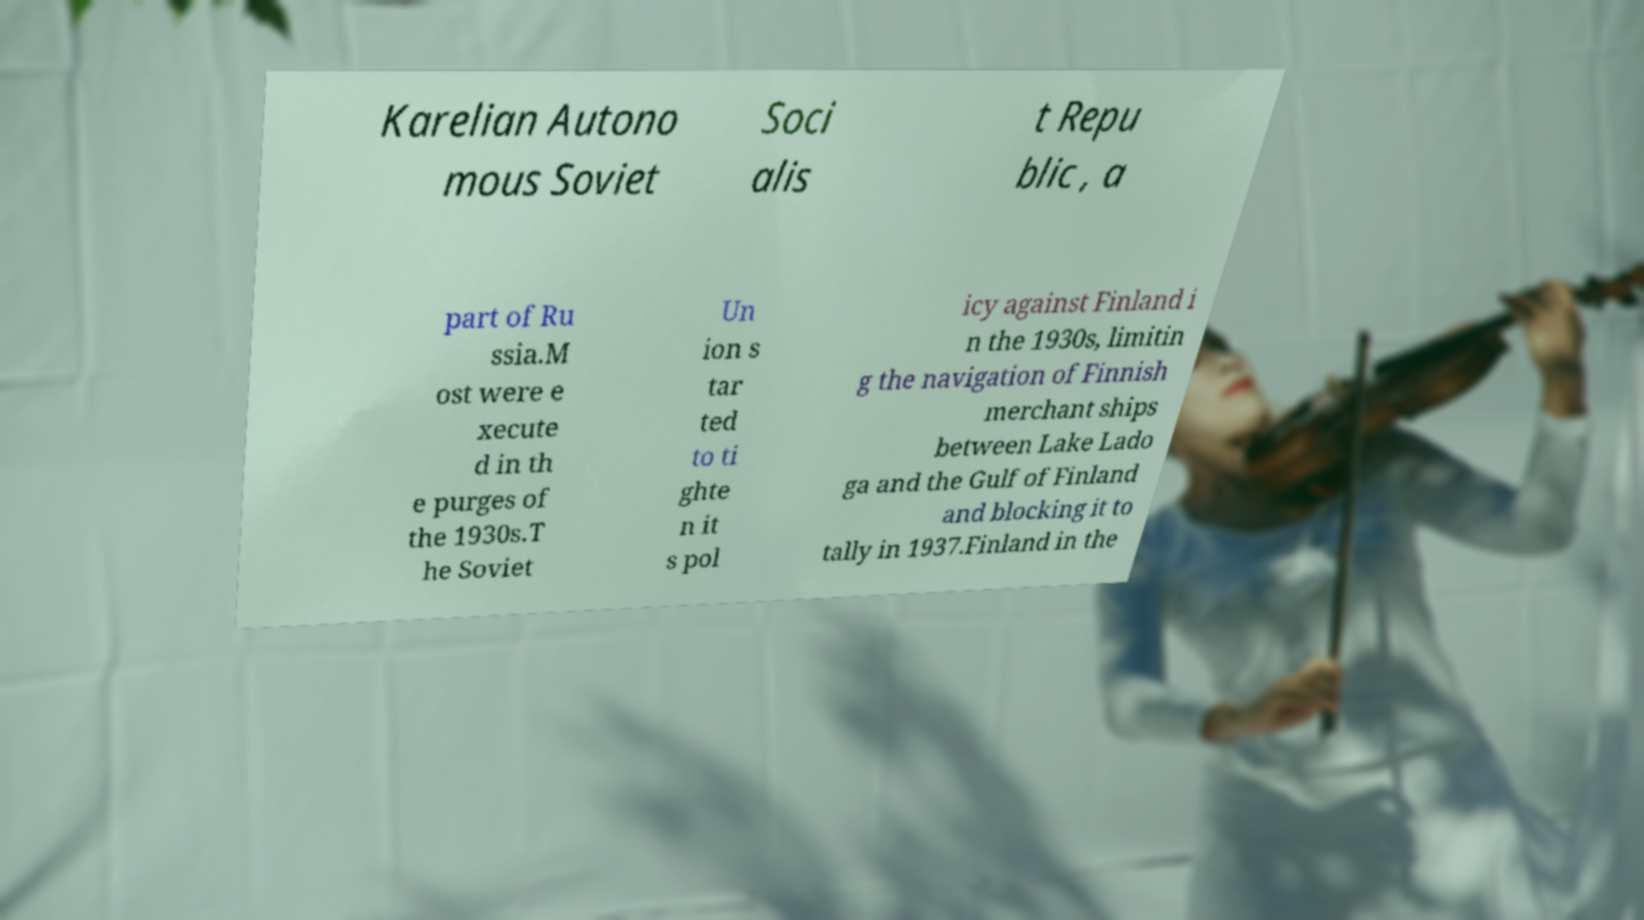Can you accurately transcribe the text from the provided image for me? Karelian Autono mous Soviet Soci alis t Repu blic , a part of Ru ssia.M ost were e xecute d in th e purges of the 1930s.T he Soviet Un ion s tar ted to ti ghte n it s pol icy against Finland i n the 1930s, limitin g the navigation of Finnish merchant ships between Lake Lado ga and the Gulf of Finland and blocking it to tally in 1937.Finland in the 